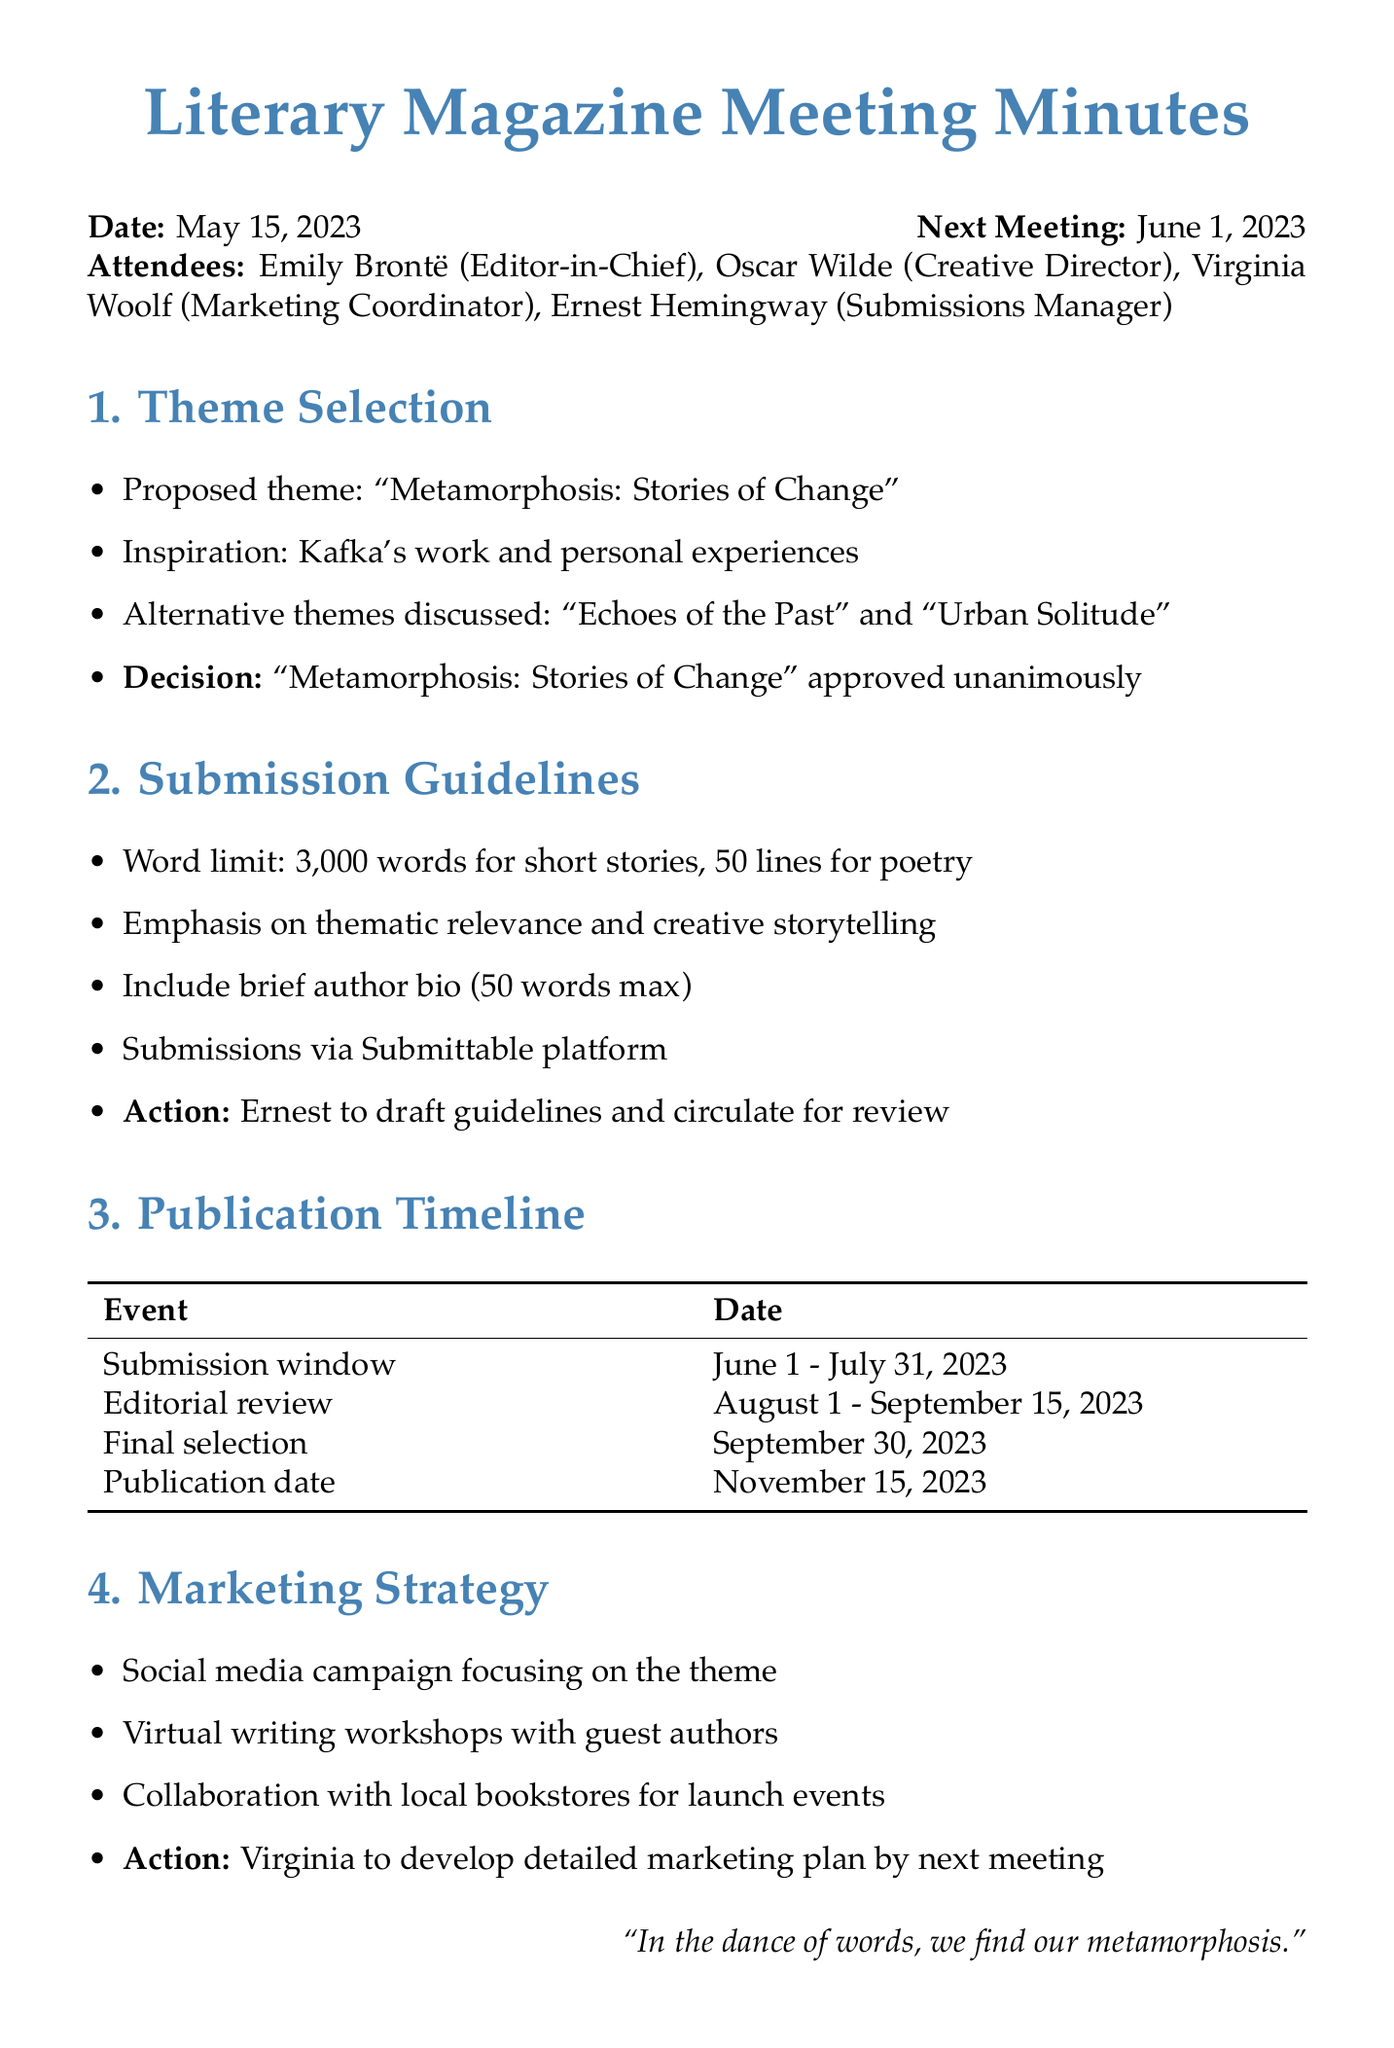What is the date of the meeting? The date of the meeting is stated at the top of the minutes.
Answer: May 15, 2023 Who is the Editor-in-Chief? The document lists the attendees and their roles, identifying the Editor-in-Chief.
Answer: Emily Brontë What is the approved theme for the magazine? The theme selection section includes the approved theme for the publication.
Answer: Metamorphosis: Stories of Change What is the word limit for short stories? The submission guidelines specify the word limit for short stories.
Answer: 3,000 words What date range is the submission window? The publication timeline outlines the submission window dates.
Answer: June 1 - July 31, 2023 Who is responsible for drafting the submission guidelines? The action item specifies who will draft the submission guidelines.
Answer: Ernest What types of events are planned for marketing? The marketing strategy lists different ideas for promoting the magazine.
Answer: Social media campaign, virtual writing workshops, collaboration with local bookstores When is the next meeting scheduled? The date for the next meeting is mentioned at the beginning of the minutes.
Answer: June 1, 2023 